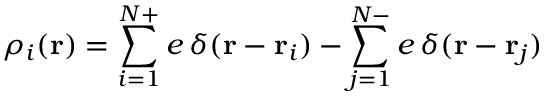<formula> <loc_0><loc_0><loc_500><loc_500>\rho _ { i } ( r ) = \sum _ { i = 1 } ^ { N + } e \, \delta ( r - r _ { i } ) - \sum _ { j = 1 } ^ { N - } e \, \delta ( r - r _ { j } )</formula> 